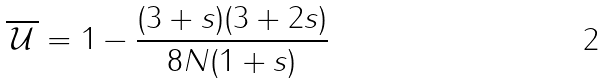Convert formula to latex. <formula><loc_0><loc_0><loc_500><loc_500>\overline { \, \mathcal { U } \, } = 1 - \frac { ( 3 + s ) ( 3 + 2 s ) } { 8 N ( 1 + s ) }</formula> 